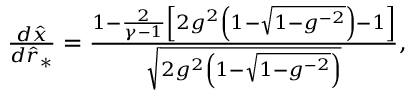Convert formula to latex. <formula><loc_0><loc_0><loc_500><loc_500>\begin{array} { r } { \frac { d \hat { x } } { d \hat { r } _ { * } } = \frac { 1 - \frac { 2 } { \gamma - 1 } \left [ 2 g ^ { 2 } \left ( 1 - \sqrt { 1 - g ^ { - 2 } } \right ) - 1 \right ] } { \sqrt { 2 g ^ { 2 } \left ( 1 - \sqrt { 1 - g ^ { - 2 } } \right ) } } , } \end{array}</formula> 